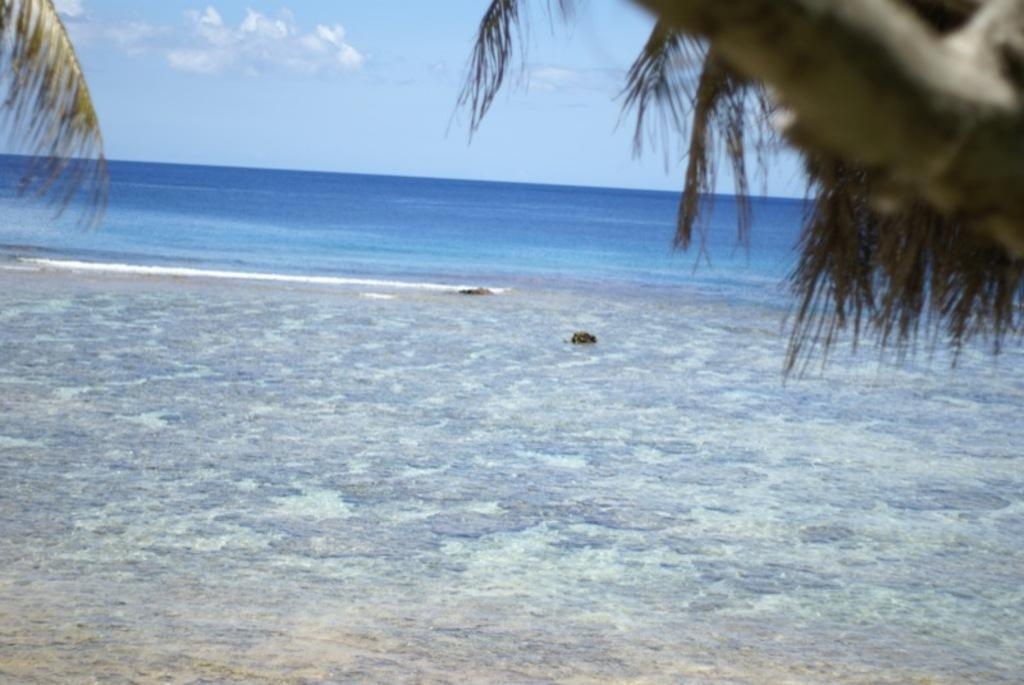What type of natural body of water is present in the image? There is a sea in the image. What type of vegetation can be seen in the image? Leaves are visible in the image. What else is visible in the image besides the sea and leaves? The sky is visible in the image. What type of connection can be seen between the leaves and the sea in the image? There is no connection between the leaves and the sea in the image; they are separate elements. 